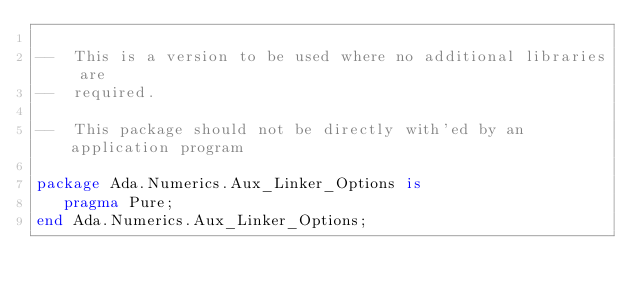<code> <loc_0><loc_0><loc_500><loc_500><_Ada_>
--  This is a version to be used where no additional libraries are
--  required.

--  This package should not be directly with'ed by an application program

package Ada.Numerics.Aux_Linker_Options is
   pragma Pure;
end Ada.Numerics.Aux_Linker_Options;
</code> 